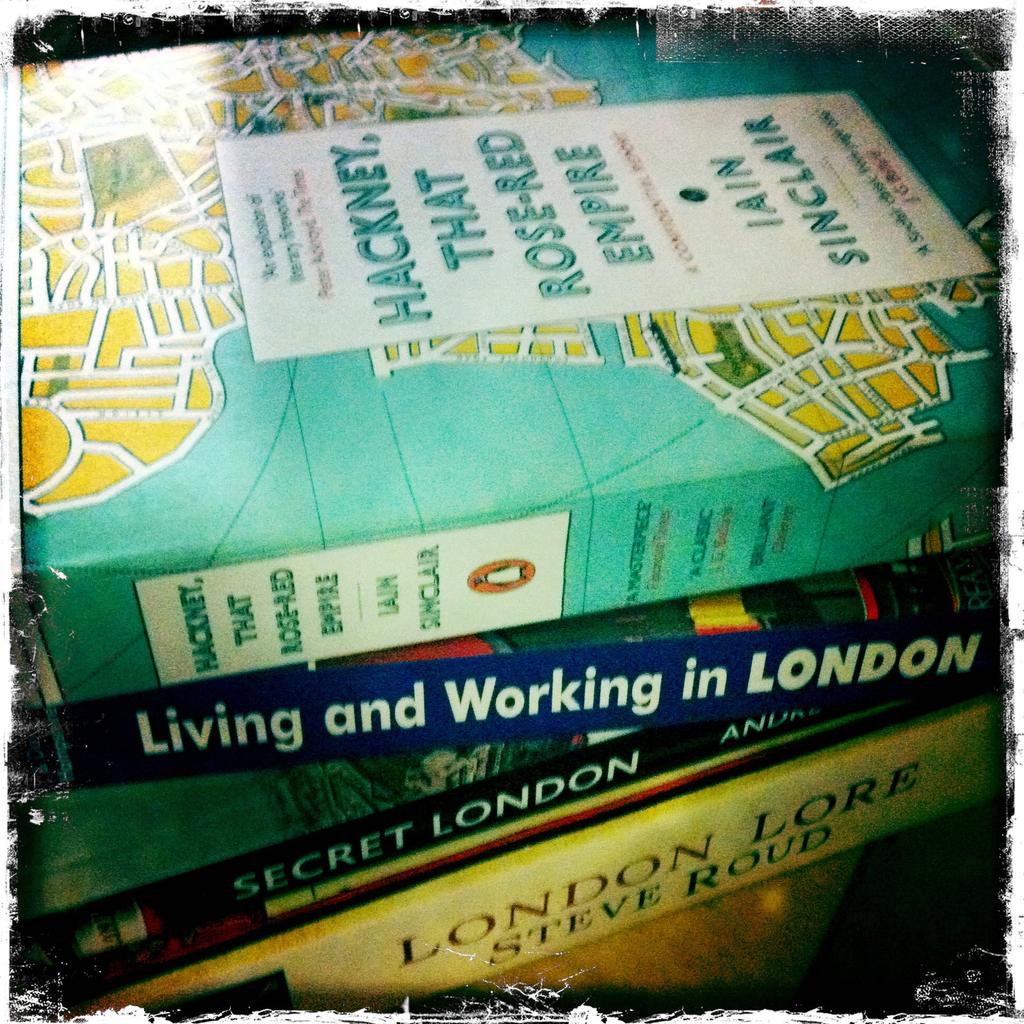Who wrote the book on top of the stack?
Provide a short and direct response. Iain sinclair. What is the title of the second book from the top?
Your answer should be compact. Living and working in london. 